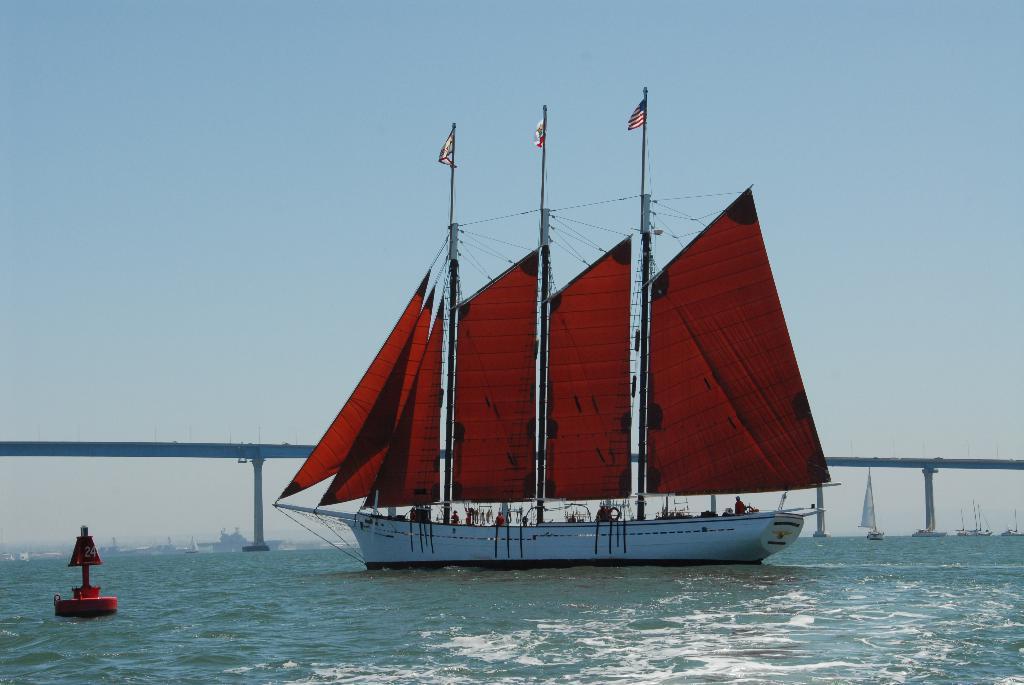How would you summarize this image in a sentence or two? In this image I can see boats on the water. Here I can see a red color object on the water. In the background I can see a bridge and the sky. 